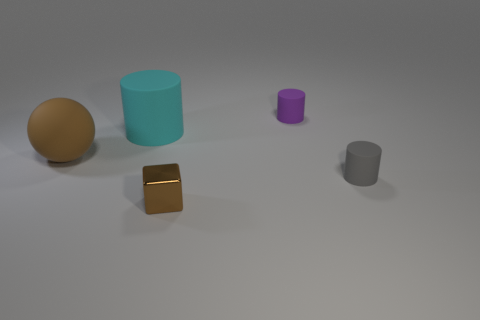Subtract all small rubber cylinders. How many cylinders are left? 1 Subtract all cylinders. How many objects are left? 2 Add 3 small brown things. How many small brown things are left? 4 Add 1 small purple cylinders. How many small purple cylinders exist? 2 Add 4 brown blocks. How many objects exist? 9 Subtract all cyan cylinders. How many cylinders are left? 2 Subtract 0 red cylinders. How many objects are left? 5 Subtract all cyan blocks. Subtract all brown spheres. How many blocks are left? 1 Subtract all brown cubes. How many blue balls are left? 0 Subtract all tiny metal blocks. Subtract all purple cylinders. How many objects are left? 3 